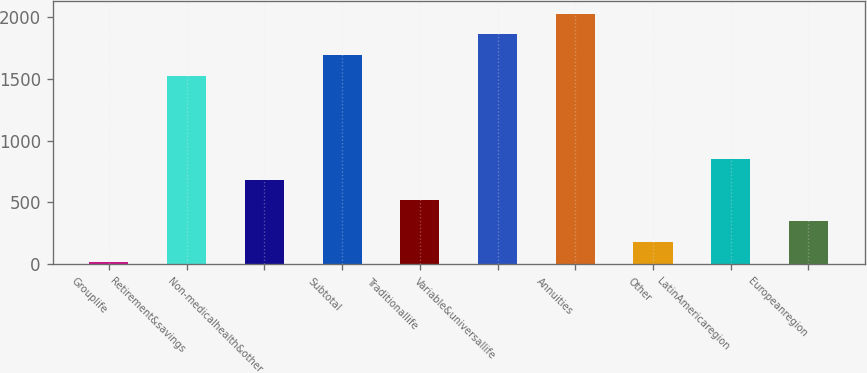Convert chart to OTSL. <chart><loc_0><loc_0><loc_500><loc_500><bar_chart><fcel>Grouplife<fcel>Retirement&savings<fcel>Non-medicalhealth&other<fcel>Subtotal<fcel>Traditionallife<fcel>Variable&universallife<fcel>Annuities<fcel>Other<fcel>LatinAmericaregion<fcel>Europeanregion<nl><fcel>15<fcel>1524.3<fcel>685.8<fcel>1692<fcel>518.1<fcel>1859.7<fcel>2027.4<fcel>182.7<fcel>853.5<fcel>350.4<nl></chart> 